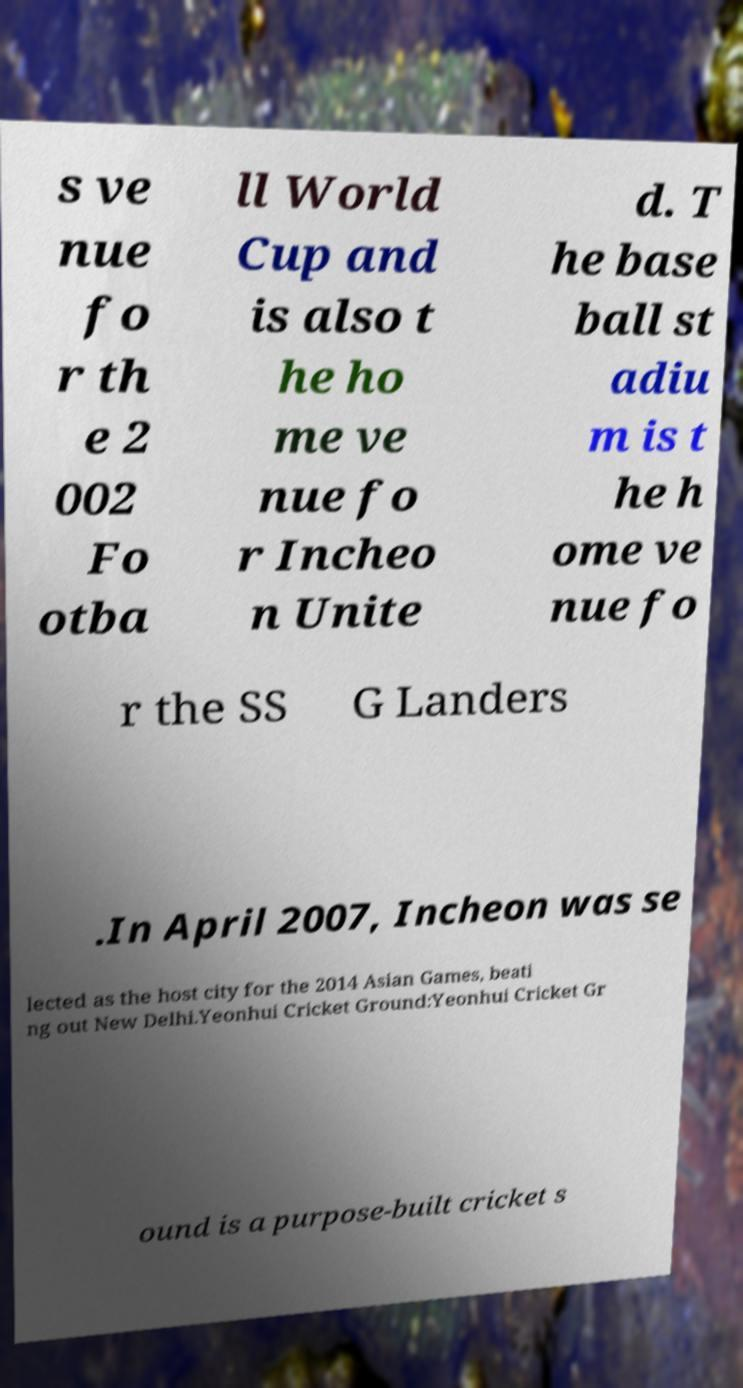Can you read and provide the text displayed in the image?This photo seems to have some interesting text. Can you extract and type it out for me? s ve nue fo r th e 2 002 Fo otba ll World Cup and is also t he ho me ve nue fo r Incheo n Unite d. T he base ball st adiu m is t he h ome ve nue fo r the SS G Landers .In April 2007, Incheon was se lected as the host city for the 2014 Asian Games, beati ng out New Delhi.Yeonhui Cricket Ground:Yeonhui Cricket Gr ound is a purpose-built cricket s 